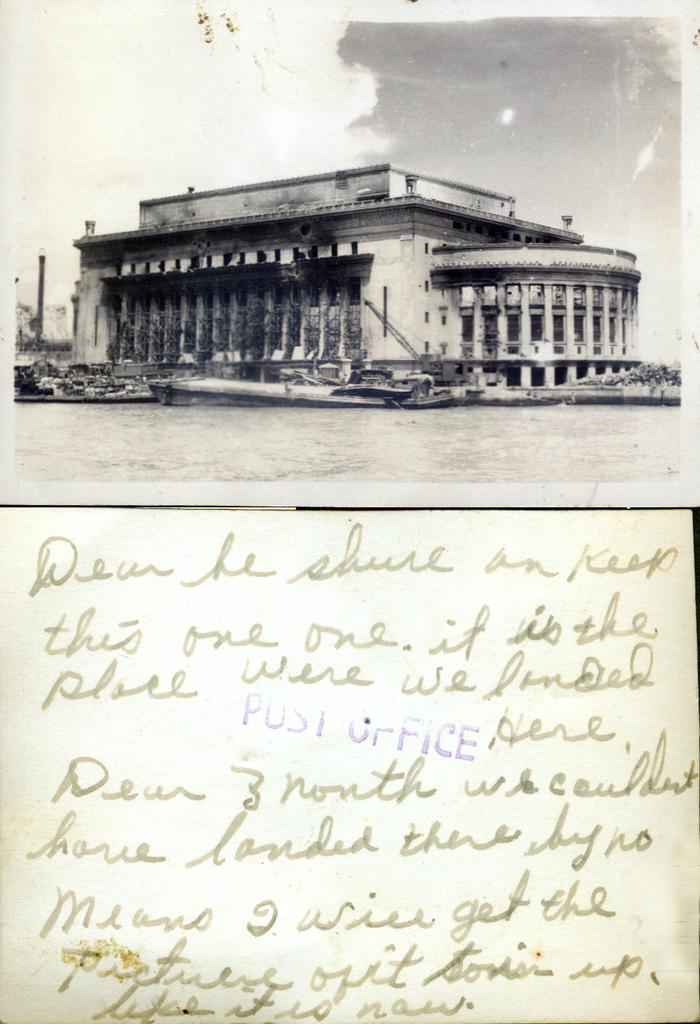Who stamped the postcard with blue?
Your answer should be compact. Post office. 